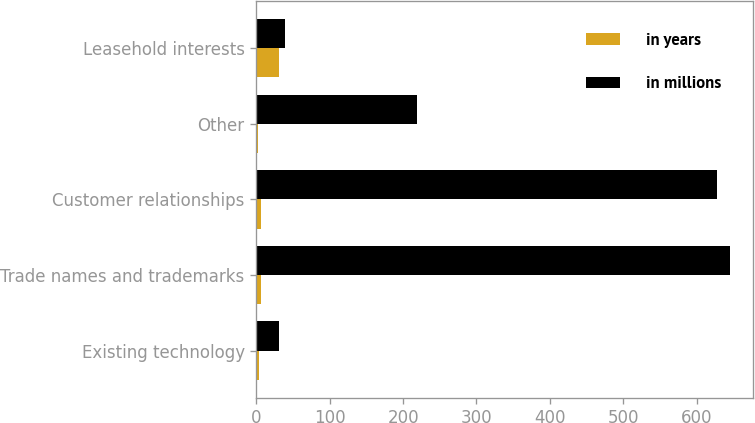<chart> <loc_0><loc_0><loc_500><loc_500><stacked_bar_chart><ecel><fcel>Existing technology<fcel>Trade names and trademarks<fcel>Customer relationships<fcel>Other<fcel>Leasehold interests<nl><fcel>in years<fcel>3<fcel>7<fcel>6<fcel>2<fcel>31<nl><fcel>in millions<fcel>31<fcel>645<fcel>628<fcel>219<fcel>39<nl></chart> 